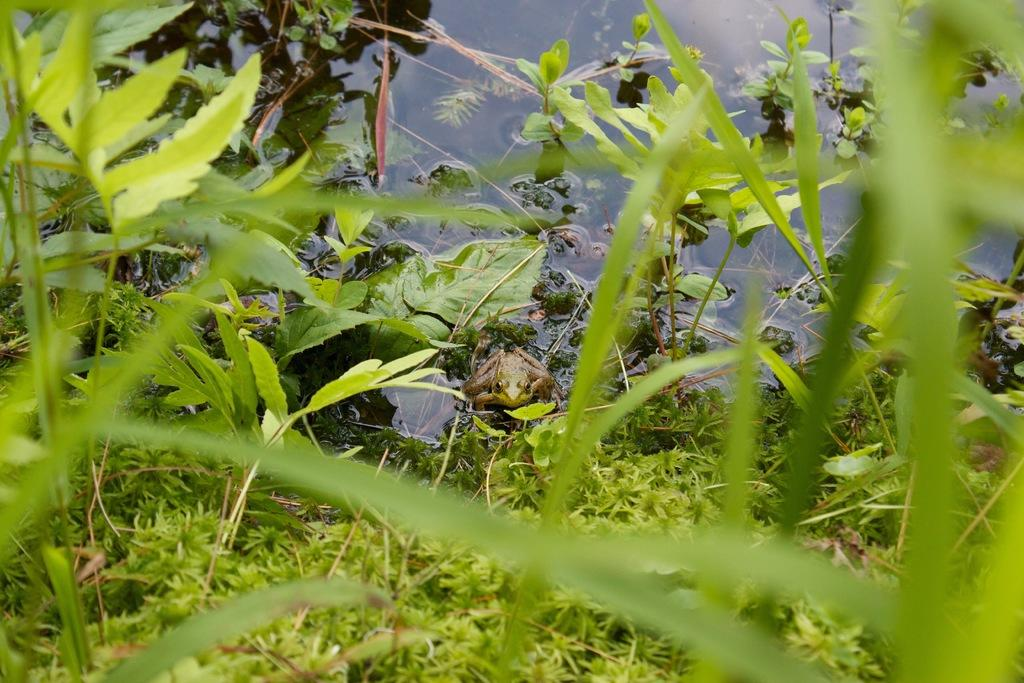What is the main subject in the center of the image? There is a frog in the center of the image. What can be seen in the background of the image? There are plants and water visible in the background of the image. What type of rhythm can be heard coming from the frog in the image? There is no sound or rhythm associated with the frog in the image, as it is a still image. 